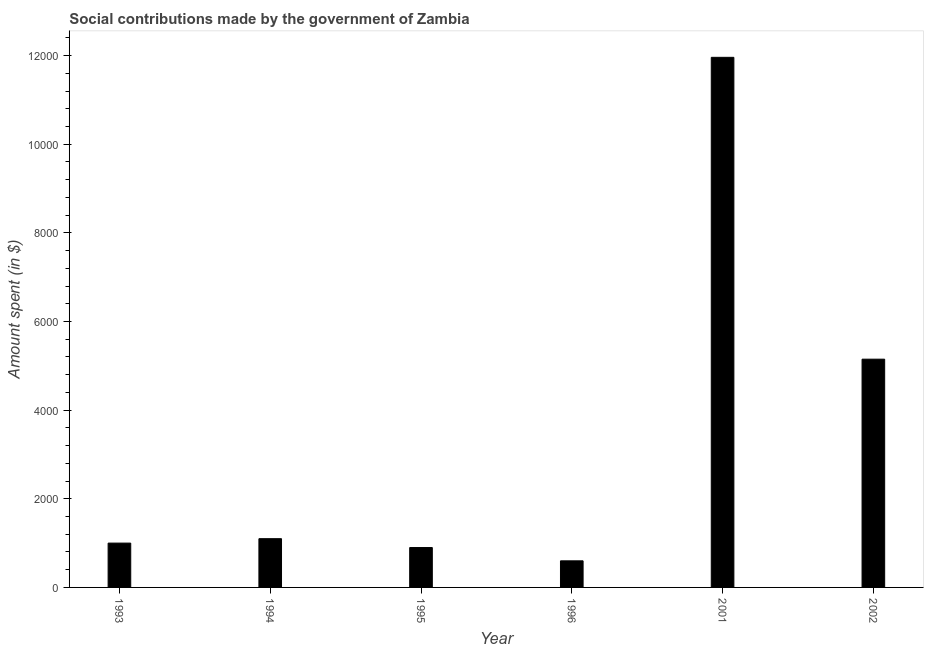What is the title of the graph?
Give a very brief answer. Social contributions made by the government of Zambia. What is the label or title of the X-axis?
Keep it short and to the point. Year. What is the label or title of the Y-axis?
Keep it short and to the point. Amount spent (in $). Across all years, what is the maximum amount spent in making social contributions?
Offer a terse response. 1.20e+04. Across all years, what is the minimum amount spent in making social contributions?
Offer a terse response. 600. What is the sum of the amount spent in making social contributions?
Ensure brevity in your answer.  2.07e+04. What is the difference between the amount spent in making social contributions in 2001 and 2002?
Offer a very short reply. 6810.51. What is the average amount spent in making social contributions per year?
Provide a succinct answer. 3451.75. What is the median amount spent in making social contributions?
Provide a short and direct response. 1050. In how many years, is the amount spent in making social contributions greater than 7600 $?
Make the answer very short. 1. Do a majority of the years between 2001 and 1995 (inclusive) have amount spent in making social contributions greater than 11600 $?
Offer a very short reply. Yes. What is the ratio of the amount spent in making social contributions in 1993 to that in 2002?
Provide a succinct answer. 0.19. Is the amount spent in making social contributions in 1993 less than that in 2001?
Your response must be concise. Yes. What is the difference between the highest and the second highest amount spent in making social contributions?
Give a very brief answer. 6810.51. What is the difference between the highest and the lowest amount spent in making social contributions?
Make the answer very short. 1.14e+04. How many bars are there?
Ensure brevity in your answer.  6. What is the difference between two consecutive major ticks on the Y-axis?
Your answer should be very brief. 2000. Are the values on the major ticks of Y-axis written in scientific E-notation?
Your answer should be compact. No. What is the Amount spent (in $) of 1993?
Give a very brief answer. 1000. What is the Amount spent (in $) in 1994?
Offer a very short reply. 1100. What is the Amount spent (in $) in 1995?
Make the answer very short. 900. What is the Amount spent (in $) of 1996?
Your answer should be compact. 600. What is the Amount spent (in $) in 2001?
Your answer should be compact. 1.20e+04. What is the Amount spent (in $) in 2002?
Provide a short and direct response. 5150. What is the difference between the Amount spent (in $) in 1993 and 1994?
Make the answer very short. -100. What is the difference between the Amount spent (in $) in 1993 and 2001?
Give a very brief answer. -1.10e+04. What is the difference between the Amount spent (in $) in 1993 and 2002?
Your response must be concise. -4150. What is the difference between the Amount spent (in $) in 1994 and 1995?
Your answer should be very brief. 200. What is the difference between the Amount spent (in $) in 1994 and 2001?
Provide a short and direct response. -1.09e+04. What is the difference between the Amount spent (in $) in 1994 and 2002?
Your answer should be compact. -4050. What is the difference between the Amount spent (in $) in 1995 and 1996?
Offer a terse response. 300. What is the difference between the Amount spent (in $) in 1995 and 2001?
Your response must be concise. -1.11e+04. What is the difference between the Amount spent (in $) in 1995 and 2002?
Give a very brief answer. -4250. What is the difference between the Amount spent (in $) in 1996 and 2001?
Your answer should be very brief. -1.14e+04. What is the difference between the Amount spent (in $) in 1996 and 2002?
Make the answer very short. -4550. What is the difference between the Amount spent (in $) in 2001 and 2002?
Keep it short and to the point. 6810.51. What is the ratio of the Amount spent (in $) in 1993 to that in 1994?
Make the answer very short. 0.91. What is the ratio of the Amount spent (in $) in 1993 to that in 1995?
Offer a very short reply. 1.11. What is the ratio of the Amount spent (in $) in 1993 to that in 1996?
Provide a short and direct response. 1.67. What is the ratio of the Amount spent (in $) in 1993 to that in 2001?
Offer a terse response. 0.08. What is the ratio of the Amount spent (in $) in 1993 to that in 2002?
Provide a short and direct response. 0.19. What is the ratio of the Amount spent (in $) in 1994 to that in 1995?
Your answer should be very brief. 1.22. What is the ratio of the Amount spent (in $) in 1994 to that in 1996?
Give a very brief answer. 1.83. What is the ratio of the Amount spent (in $) in 1994 to that in 2001?
Your response must be concise. 0.09. What is the ratio of the Amount spent (in $) in 1994 to that in 2002?
Provide a short and direct response. 0.21. What is the ratio of the Amount spent (in $) in 1995 to that in 2001?
Your answer should be compact. 0.07. What is the ratio of the Amount spent (in $) in 1995 to that in 2002?
Ensure brevity in your answer.  0.17. What is the ratio of the Amount spent (in $) in 1996 to that in 2001?
Offer a terse response. 0.05. What is the ratio of the Amount spent (in $) in 1996 to that in 2002?
Offer a very short reply. 0.12. What is the ratio of the Amount spent (in $) in 2001 to that in 2002?
Your answer should be very brief. 2.32. 